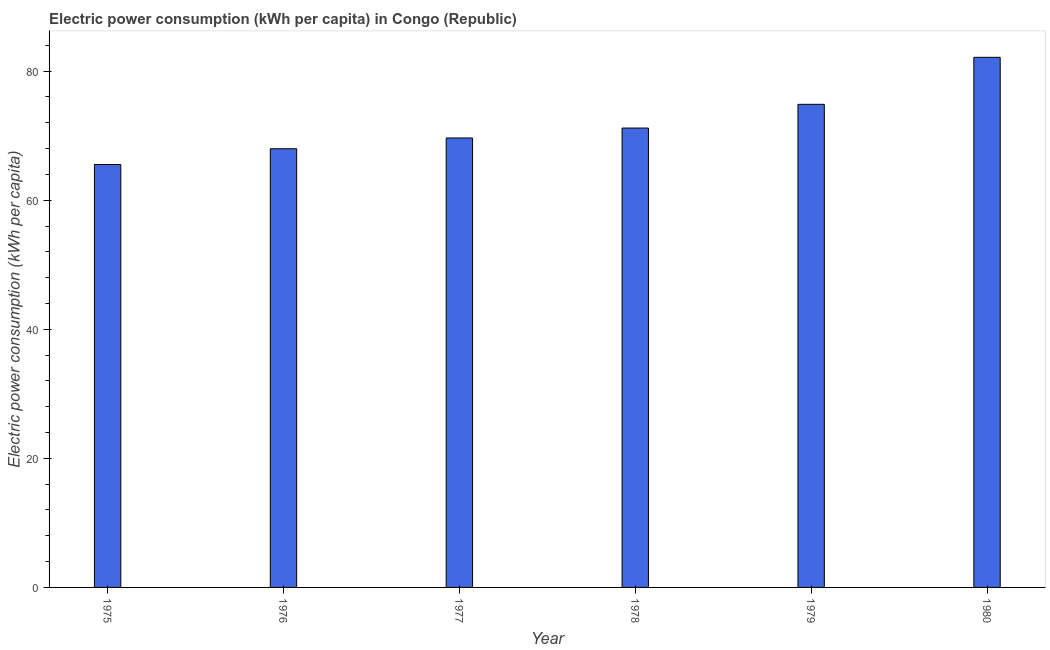Does the graph contain any zero values?
Make the answer very short. No. What is the title of the graph?
Your response must be concise. Electric power consumption (kWh per capita) in Congo (Republic). What is the label or title of the X-axis?
Offer a very short reply. Year. What is the label or title of the Y-axis?
Provide a succinct answer. Electric power consumption (kWh per capita). What is the electric power consumption in 1977?
Give a very brief answer. 69.65. Across all years, what is the maximum electric power consumption?
Your answer should be compact. 82.15. Across all years, what is the minimum electric power consumption?
Ensure brevity in your answer.  65.54. In which year was the electric power consumption maximum?
Offer a very short reply. 1980. In which year was the electric power consumption minimum?
Provide a short and direct response. 1975. What is the sum of the electric power consumption?
Provide a short and direct response. 431.36. What is the difference between the electric power consumption in 1978 and 1980?
Provide a succinct answer. -10.96. What is the average electric power consumption per year?
Provide a succinct answer. 71.89. What is the median electric power consumption?
Offer a very short reply. 70.42. In how many years, is the electric power consumption greater than 48 kWh per capita?
Make the answer very short. 6. What is the ratio of the electric power consumption in 1975 to that in 1978?
Your response must be concise. 0.92. Is the difference between the electric power consumption in 1976 and 1977 greater than the difference between any two years?
Offer a terse response. No. What is the difference between the highest and the second highest electric power consumption?
Provide a succinct answer. 7.28. Is the sum of the electric power consumption in 1976 and 1977 greater than the maximum electric power consumption across all years?
Provide a short and direct response. Yes. What is the difference between the highest and the lowest electric power consumption?
Offer a terse response. 16.61. How many bars are there?
Offer a very short reply. 6. Are all the bars in the graph horizontal?
Ensure brevity in your answer.  No. What is the difference between two consecutive major ticks on the Y-axis?
Make the answer very short. 20. Are the values on the major ticks of Y-axis written in scientific E-notation?
Give a very brief answer. No. What is the Electric power consumption (kWh per capita) in 1975?
Provide a succinct answer. 65.54. What is the Electric power consumption (kWh per capita) in 1976?
Provide a succinct answer. 67.98. What is the Electric power consumption (kWh per capita) of 1977?
Offer a terse response. 69.65. What is the Electric power consumption (kWh per capita) of 1978?
Offer a very short reply. 71.19. What is the Electric power consumption (kWh per capita) of 1979?
Your answer should be very brief. 74.86. What is the Electric power consumption (kWh per capita) of 1980?
Give a very brief answer. 82.15. What is the difference between the Electric power consumption (kWh per capita) in 1975 and 1976?
Your response must be concise. -2.44. What is the difference between the Electric power consumption (kWh per capita) in 1975 and 1977?
Make the answer very short. -4.11. What is the difference between the Electric power consumption (kWh per capita) in 1975 and 1978?
Your answer should be very brief. -5.65. What is the difference between the Electric power consumption (kWh per capita) in 1975 and 1979?
Make the answer very short. -9.33. What is the difference between the Electric power consumption (kWh per capita) in 1975 and 1980?
Your answer should be compact. -16.61. What is the difference between the Electric power consumption (kWh per capita) in 1976 and 1977?
Give a very brief answer. -1.67. What is the difference between the Electric power consumption (kWh per capita) in 1976 and 1978?
Offer a very short reply. -3.21. What is the difference between the Electric power consumption (kWh per capita) in 1976 and 1979?
Your answer should be very brief. -6.88. What is the difference between the Electric power consumption (kWh per capita) in 1976 and 1980?
Provide a succinct answer. -14.17. What is the difference between the Electric power consumption (kWh per capita) in 1977 and 1978?
Provide a succinct answer. -1.54. What is the difference between the Electric power consumption (kWh per capita) in 1977 and 1979?
Your answer should be very brief. -5.21. What is the difference between the Electric power consumption (kWh per capita) in 1977 and 1980?
Your response must be concise. -12.5. What is the difference between the Electric power consumption (kWh per capita) in 1978 and 1979?
Your response must be concise. -3.68. What is the difference between the Electric power consumption (kWh per capita) in 1978 and 1980?
Your answer should be compact. -10.96. What is the difference between the Electric power consumption (kWh per capita) in 1979 and 1980?
Offer a very short reply. -7.28. What is the ratio of the Electric power consumption (kWh per capita) in 1975 to that in 1977?
Offer a terse response. 0.94. What is the ratio of the Electric power consumption (kWh per capita) in 1975 to that in 1978?
Your response must be concise. 0.92. What is the ratio of the Electric power consumption (kWh per capita) in 1975 to that in 1980?
Ensure brevity in your answer.  0.8. What is the ratio of the Electric power consumption (kWh per capita) in 1976 to that in 1978?
Make the answer very short. 0.95. What is the ratio of the Electric power consumption (kWh per capita) in 1976 to that in 1979?
Ensure brevity in your answer.  0.91. What is the ratio of the Electric power consumption (kWh per capita) in 1976 to that in 1980?
Offer a terse response. 0.83. What is the ratio of the Electric power consumption (kWh per capita) in 1977 to that in 1979?
Your response must be concise. 0.93. What is the ratio of the Electric power consumption (kWh per capita) in 1977 to that in 1980?
Offer a terse response. 0.85. What is the ratio of the Electric power consumption (kWh per capita) in 1978 to that in 1979?
Your answer should be very brief. 0.95. What is the ratio of the Electric power consumption (kWh per capita) in 1978 to that in 1980?
Provide a succinct answer. 0.87. What is the ratio of the Electric power consumption (kWh per capita) in 1979 to that in 1980?
Offer a terse response. 0.91. 